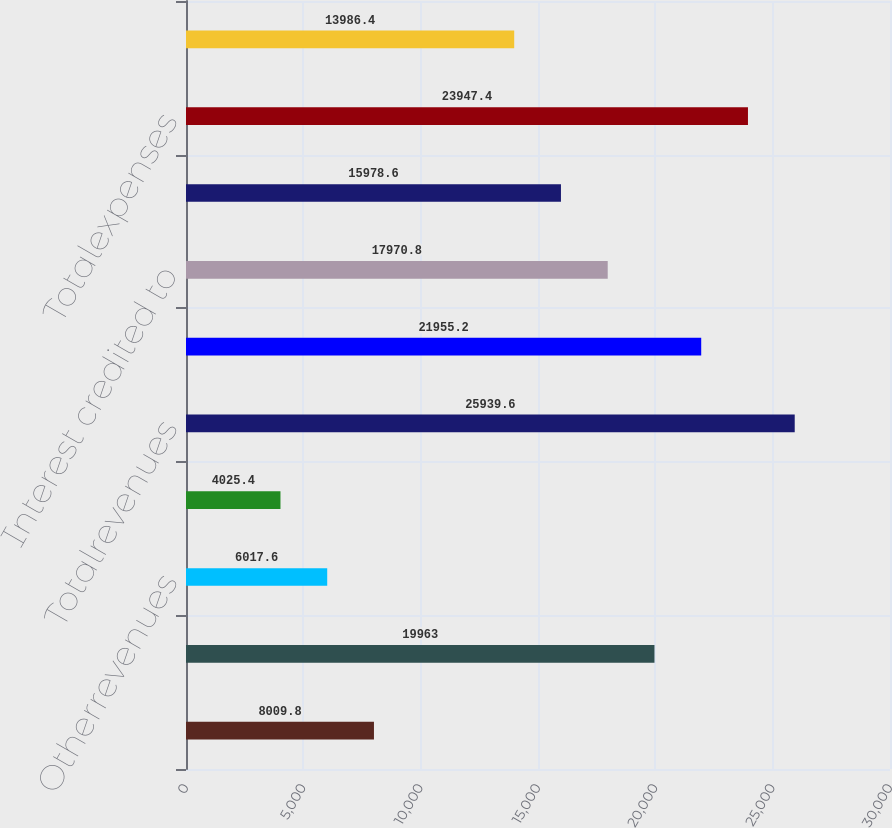<chart> <loc_0><loc_0><loc_500><loc_500><bar_chart><ecel><fcel>Netinvestmentincome<fcel>Otherrevenues<fcel>Netinvestmentgains(losses)<fcel>Totalrevenues<fcel>Policyholderbenefitsandclaims<fcel>Interest credited to<fcel>Otherexpenses<fcel>Totalexpenses<fcel>Income from continuing<nl><fcel>8009.8<fcel>19963<fcel>6017.6<fcel>4025.4<fcel>25939.6<fcel>21955.2<fcel>17970.8<fcel>15978.6<fcel>23947.4<fcel>13986.4<nl></chart> 